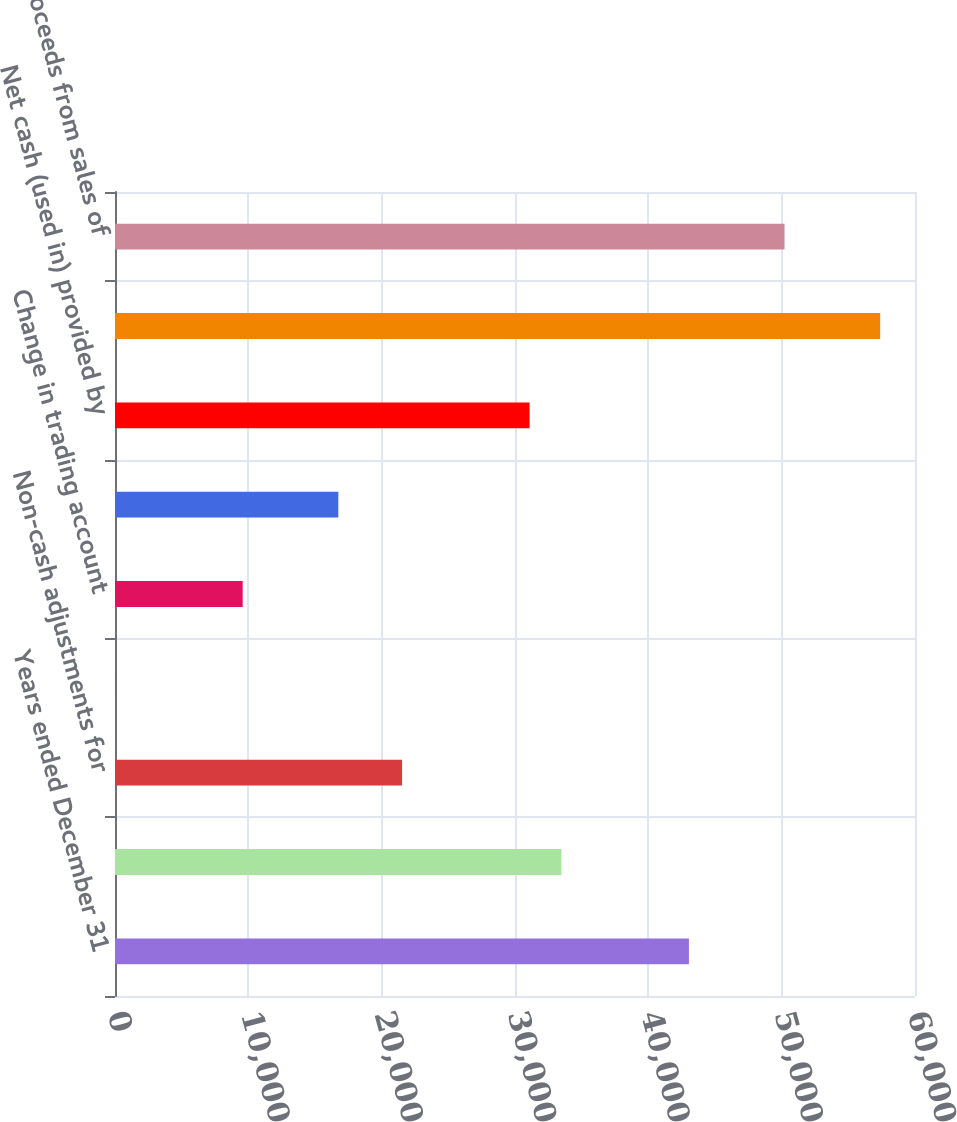Convert chart to OTSL. <chart><loc_0><loc_0><loc_500><loc_500><bar_chart><fcel>Years ended December 31<fcel>Net income<fcel>Non-cash adjustments for<fcel>(Gains) losses related to<fcel>Change in trading account<fcel>Other net<fcel>Net cash (used in) provided by<fcel>Net (increase) decrease in<fcel>Proceeds from sales of<nl><fcel>43044<fcel>33482<fcel>21529.5<fcel>15<fcel>9577<fcel>16748.5<fcel>31091.5<fcel>57387<fcel>50215.5<nl></chart> 